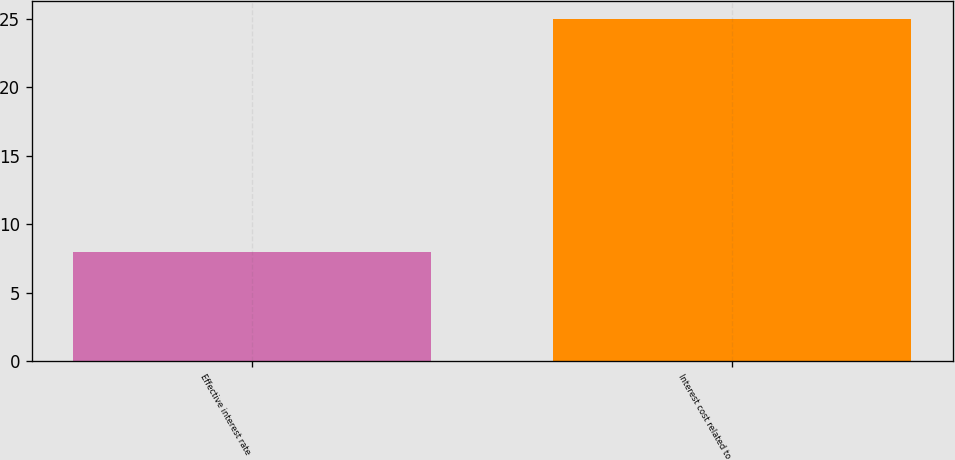Convert chart to OTSL. <chart><loc_0><loc_0><loc_500><loc_500><bar_chart><fcel>Effective interest rate<fcel>Interest cost related to<nl><fcel>8<fcel>25<nl></chart> 